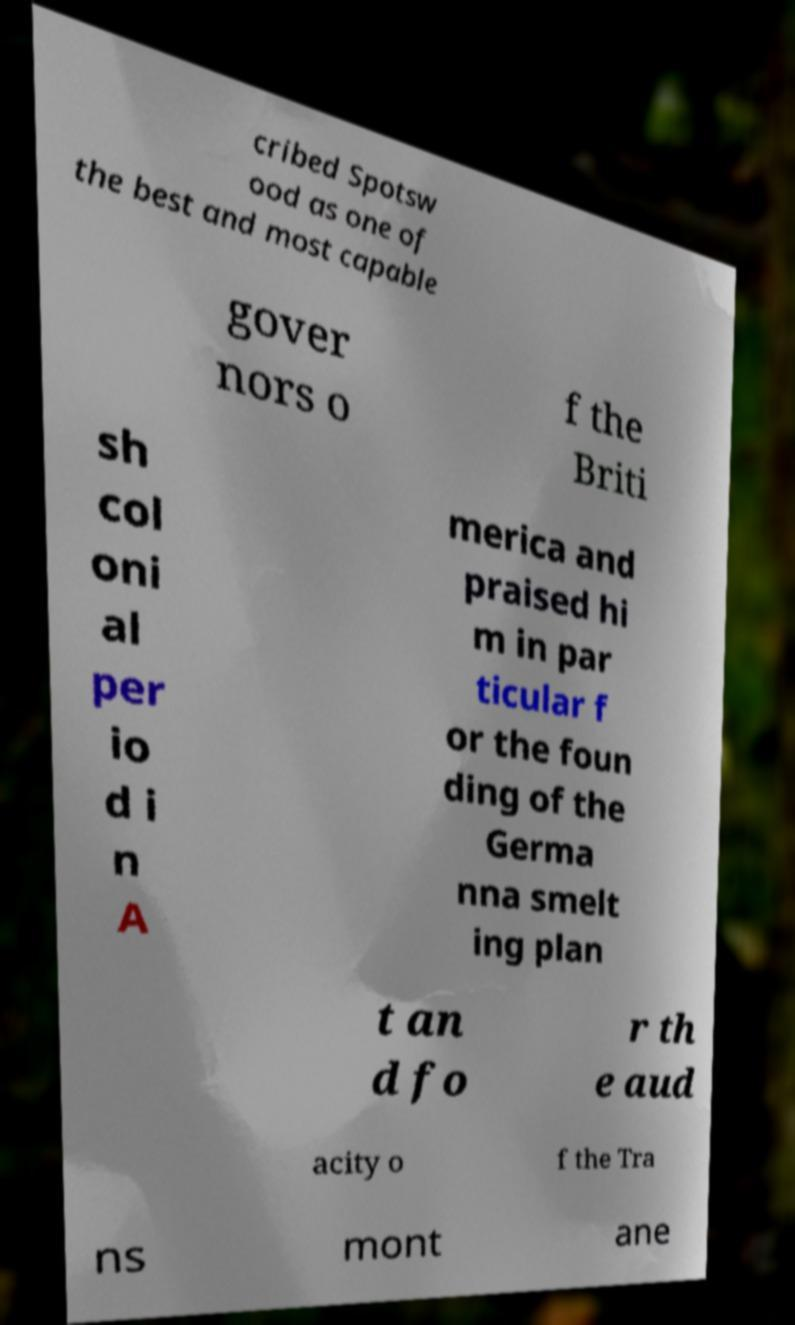Please read and relay the text visible in this image. What does it say? cribed Spotsw ood as one of the best and most capable gover nors o f the Briti sh col oni al per io d i n A merica and praised hi m in par ticular f or the foun ding of the Germa nna smelt ing plan t an d fo r th e aud acity o f the Tra ns mont ane 